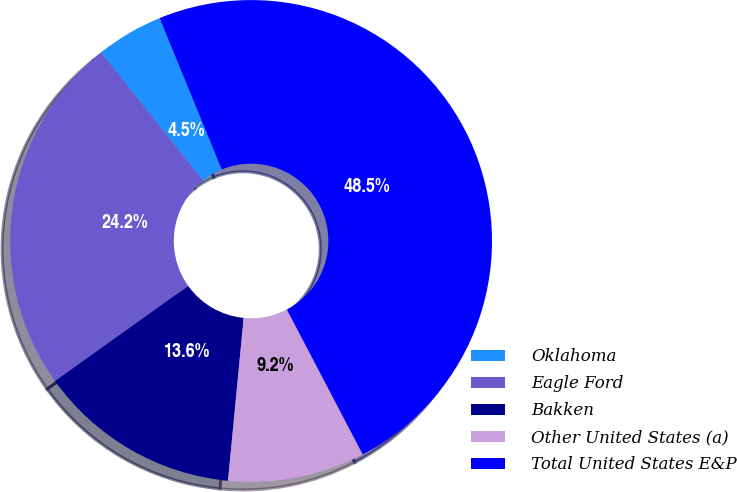<chart> <loc_0><loc_0><loc_500><loc_500><pie_chart><fcel>Oklahoma<fcel>Eagle Ford<fcel>Bakken<fcel>Other United States (a)<fcel>Total United States E&P<nl><fcel>4.51%<fcel>24.17%<fcel>13.6%<fcel>9.2%<fcel>48.52%<nl></chart> 